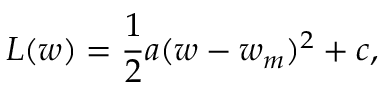<formula> <loc_0><loc_0><loc_500><loc_500>L ( w ) = \frac { 1 } { 2 } a ( w - w _ { m } ) ^ { 2 } + c ,</formula> 